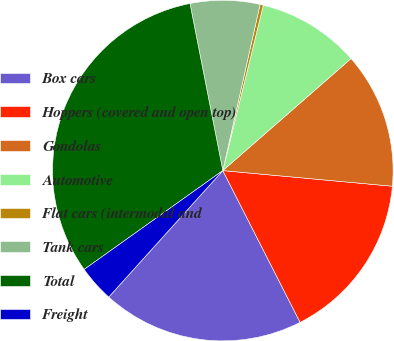<chart> <loc_0><loc_0><loc_500><loc_500><pie_chart><fcel>Box cars<fcel>Hoppers (covered and open top)<fcel>Gondolas<fcel>Automotive<fcel>Flat cars (intermodal and<fcel>Tank cars<fcel>Total<fcel>Freight<nl><fcel>19.18%<fcel>16.04%<fcel>12.89%<fcel>9.75%<fcel>0.31%<fcel>6.6%<fcel>31.77%<fcel>3.46%<nl></chart> 